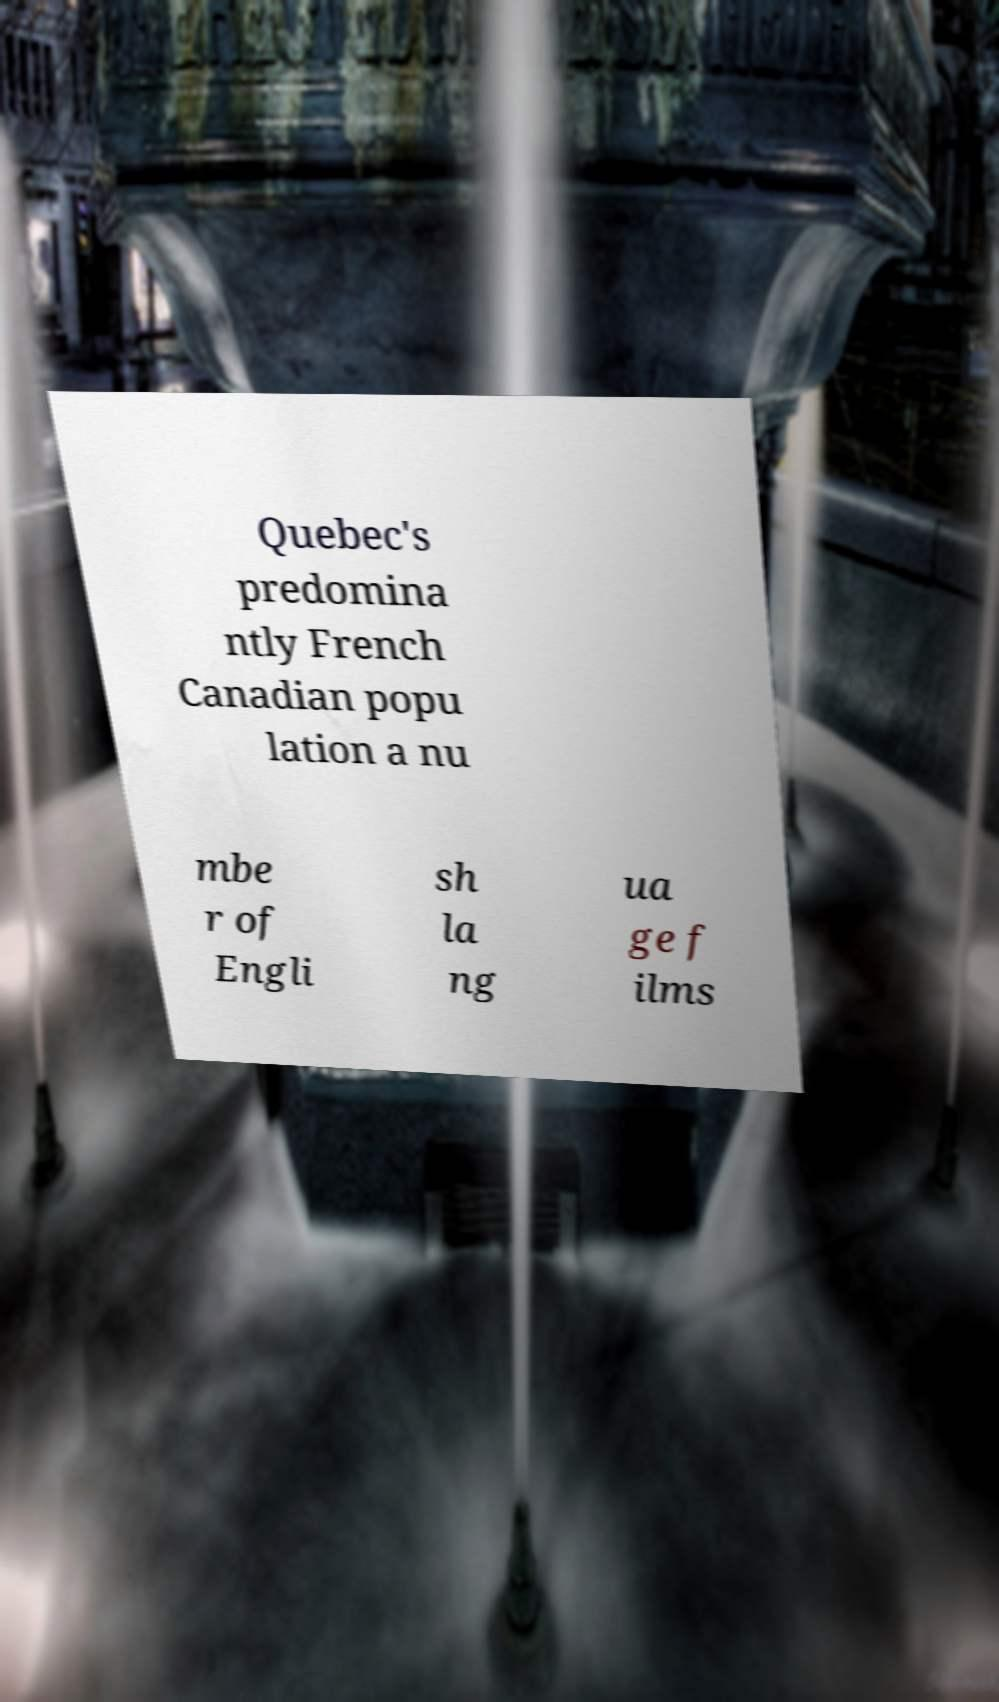Can you accurately transcribe the text from the provided image for me? Quebec's predomina ntly French Canadian popu lation a nu mbe r of Engli sh la ng ua ge f ilms 